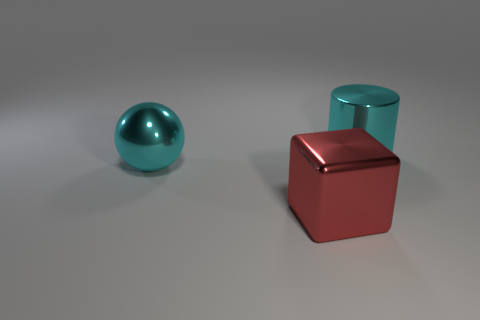There is a cyan thing behind the cyan ball that is behind the block; what is its size?
Ensure brevity in your answer.  Large. Are there the same number of red metallic things to the left of the big metal block and big metal cubes that are on the left side of the big cyan metallic ball?
Ensure brevity in your answer.  Yes. There is a cyan metallic object left of the red shiny block; are there any large shiny things on the right side of it?
Your answer should be compact. Yes. What number of cyan cylinders are behind the cyan thing that is in front of the cyan object that is on the right side of the large cyan shiny ball?
Your answer should be compact. 1. Are there fewer large gray rubber objects than big cubes?
Your answer should be compact. Yes. There is a cyan metallic thing in front of the large cyan cylinder; does it have the same shape as the big object on the right side of the red block?
Keep it short and to the point. No. The metallic cylinder has what color?
Offer a very short reply. Cyan. How many shiny objects are big cyan spheres or cyan cylinders?
Make the answer very short. 2. Are there any big purple cylinders?
Keep it short and to the point. No. Does the thing to the right of the red metal block have the same material as the large thing in front of the big cyan sphere?
Make the answer very short. Yes. 